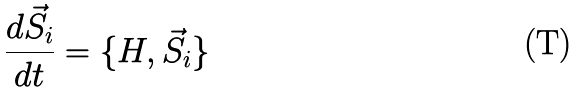Convert formula to latex. <formula><loc_0><loc_0><loc_500><loc_500>\frac { d \vec { S } _ { i } } { d t } = \{ H , \vec { S } _ { i } \}</formula> 